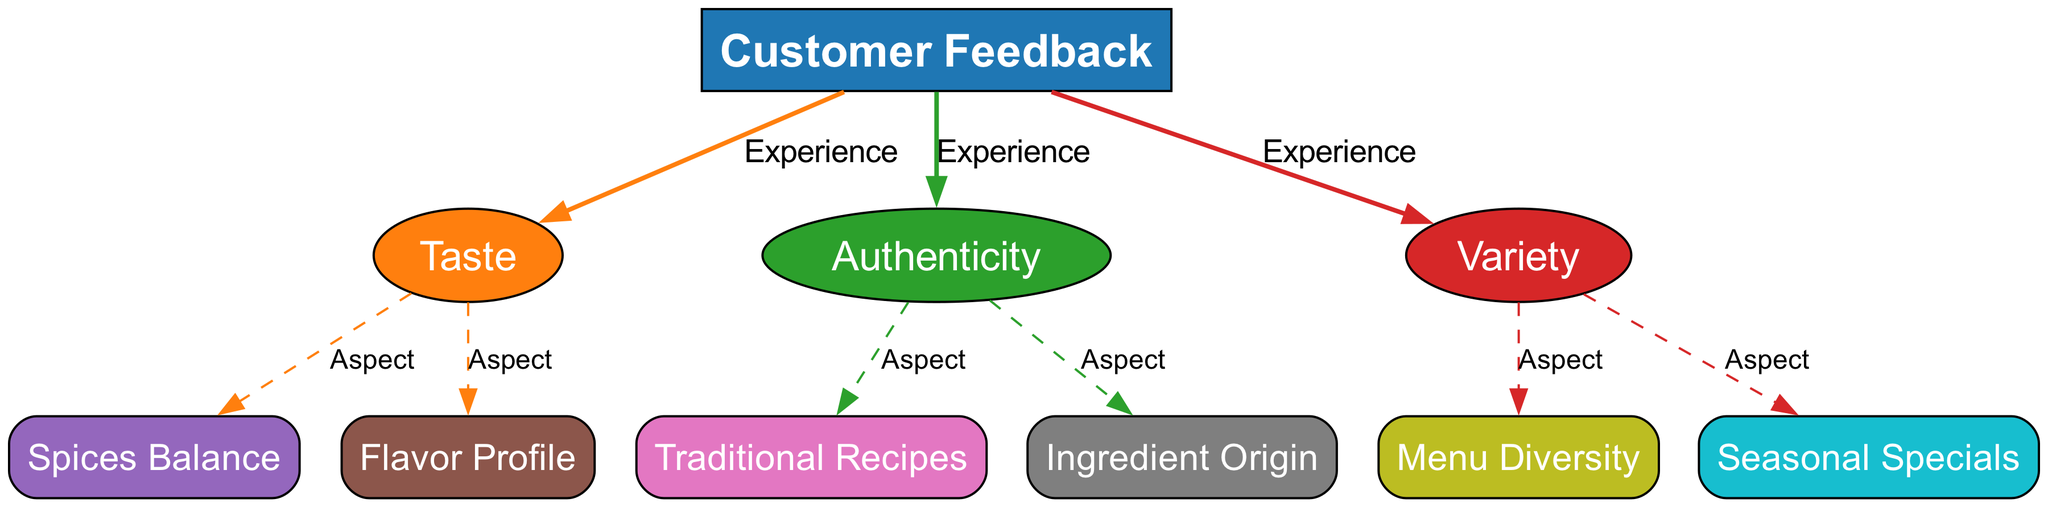What is the main topic of the diagram? The main topic is "Customer Feedback," which is represented as the root node in the diagram. This node connects to other aspects like taste, authenticity, and variety, indicating that the diagram is focused on customer feedback related to these elements.
Answer: Customer Feedback How many nodes are in the diagram? The diagram consists of 10 nodes, which include the main topic of customer feedback and various related aspects like taste, authenticity, and variety, as well as their respective components.
Answer: 10 What aspect is directly related to taste? The aspect directly related to taste includes "Spices Balance" and "Flavor Profile," which are connected to the taste node, indicating they provide information relevant to the overall flavor experience.
Answer: Spices Balance, Flavor Profile What is one of the components under authenticity? One of the components under authenticity is "Ingredient Origin." This node is linked to the authenticity node, representing a factor that contributes to the perception of a dish's authenticity.
Answer: Ingredient Origin Which aspect is associated with menu diversity? The aspect associated with menu diversity is "Variety," which connects to the "Menu Diversity" node, showing that variety in offerings is a key focus within the broader category of variety in customer feedback.
Answer: Variety Which node has the most connections? The node "Customer Feedback" has three connections, leading to the taste, authenticity, and variety nodes, indicating it is central to the diagram as it represents the overall feedback from customers.
Answer: Customer Feedback What type of edge connects the taste node to its components? The edges connecting the taste node to its components, "Spices Balance" and "Flavor Profile," are labeled "Aspect," indicating these are details or characteristics of taste rather than direct feedback.
Answer: Aspect How many aspects are related to variety? There are two aspects related to variety, which are "Menu Diversity" and "Seasonal Specials," demonstrating that variety also encompasses special menu items that may change based on seasons.
Answer: 2 Which node represents traditional recipes? The node that represents traditional recipes is "Traditional Recipes," linked under the authenticity category, indicating a specific aspect concerning the authentic nature of the food offerings.
Answer: Traditional Recipes 